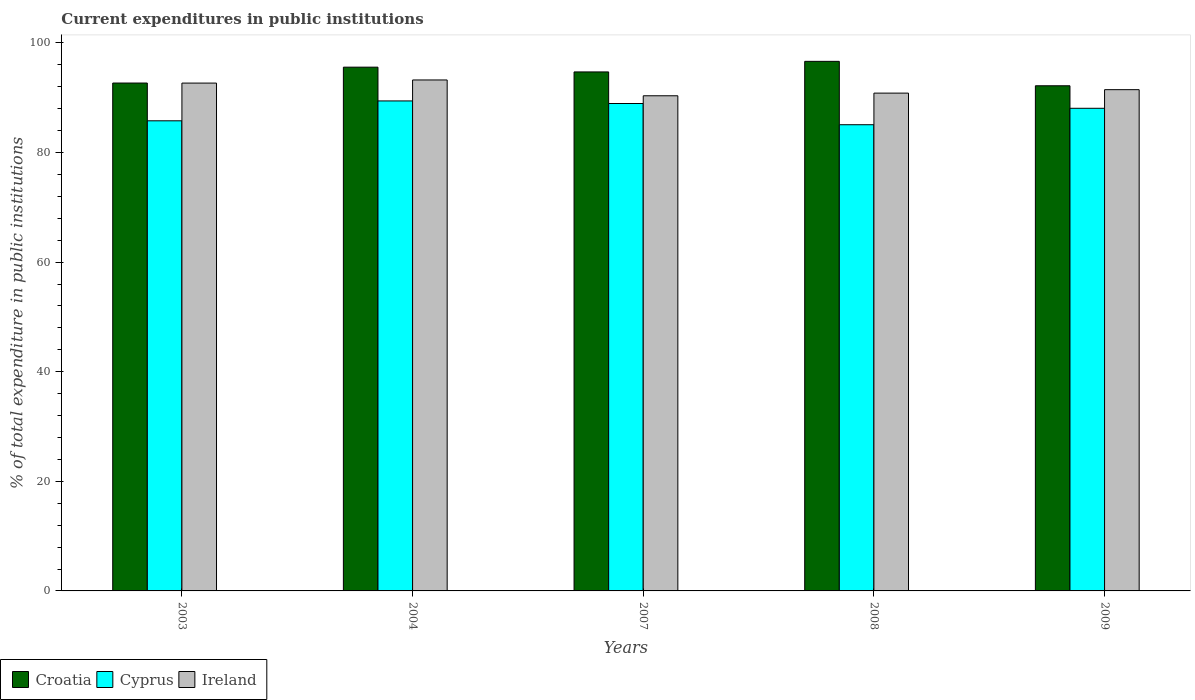How many different coloured bars are there?
Make the answer very short. 3. Are the number of bars per tick equal to the number of legend labels?
Keep it short and to the point. Yes. How many bars are there on the 3rd tick from the left?
Provide a succinct answer. 3. How many bars are there on the 1st tick from the right?
Give a very brief answer. 3. What is the current expenditures in public institutions in Croatia in 2009?
Give a very brief answer. 92.18. Across all years, what is the maximum current expenditures in public institutions in Ireland?
Keep it short and to the point. 93.24. Across all years, what is the minimum current expenditures in public institutions in Croatia?
Provide a short and direct response. 92.18. In which year was the current expenditures in public institutions in Ireland minimum?
Provide a short and direct response. 2007. What is the total current expenditures in public institutions in Ireland in the graph?
Keep it short and to the point. 458.56. What is the difference between the current expenditures in public institutions in Cyprus in 2008 and that in 2009?
Your answer should be very brief. -3. What is the difference between the current expenditures in public institutions in Cyprus in 2007 and the current expenditures in public institutions in Ireland in 2004?
Give a very brief answer. -4.3. What is the average current expenditures in public institutions in Croatia per year?
Ensure brevity in your answer.  94.35. In the year 2003, what is the difference between the current expenditures in public institutions in Cyprus and current expenditures in public institutions in Croatia?
Keep it short and to the point. -6.89. In how many years, is the current expenditures in public institutions in Ireland greater than 32 %?
Offer a terse response. 5. What is the ratio of the current expenditures in public institutions in Ireland in 2003 to that in 2007?
Give a very brief answer. 1.03. Is the current expenditures in public institutions in Croatia in 2003 less than that in 2009?
Provide a succinct answer. No. What is the difference between the highest and the second highest current expenditures in public institutions in Cyprus?
Ensure brevity in your answer.  0.47. What is the difference between the highest and the lowest current expenditures in public institutions in Ireland?
Your answer should be very brief. 2.89. In how many years, is the current expenditures in public institutions in Ireland greater than the average current expenditures in public institutions in Ireland taken over all years?
Give a very brief answer. 2. Is the sum of the current expenditures in public institutions in Ireland in 2004 and 2007 greater than the maximum current expenditures in public institutions in Cyprus across all years?
Provide a short and direct response. Yes. What does the 3rd bar from the left in 2008 represents?
Make the answer very short. Ireland. What does the 3rd bar from the right in 2007 represents?
Your answer should be compact. Croatia. How many bars are there?
Offer a very short reply. 15. What is the difference between two consecutive major ticks on the Y-axis?
Keep it short and to the point. 20. Are the values on the major ticks of Y-axis written in scientific E-notation?
Ensure brevity in your answer.  No. Where does the legend appear in the graph?
Provide a succinct answer. Bottom left. What is the title of the graph?
Make the answer very short. Current expenditures in public institutions. Does "Cyprus" appear as one of the legend labels in the graph?
Provide a short and direct response. Yes. What is the label or title of the Y-axis?
Offer a very short reply. % of total expenditure in public institutions. What is the % of total expenditure in public institutions of Croatia in 2003?
Offer a terse response. 92.68. What is the % of total expenditure in public institutions of Cyprus in 2003?
Offer a very short reply. 85.78. What is the % of total expenditure in public institutions of Ireland in 2003?
Make the answer very short. 92.67. What is the % of total expenditure in public institutions of Croatia in 2004?
Your answer should be compact. 95.57. What is the % of total expenditure in public institutions in Cyprus in 2004?
Your response must be concise. 89.41. What is the % of total expenditure in public institutions of Ireland in 2004?
Provide a short and direct response. 93.24. What is the % of total expenditure in public institutions of Croatia in 2007?
Offer a very short reply. 94.7. What is the % of total expenditure in public institutions in Cyprus in 2007?
Your answer should be very brief. 88.94. What is the % of total expenditure in public institutions in Ireland in 2007?
Provide a short and direct response. 90.35. What is the % of total expenditure in public institutions of Croatia in 2008?
Provide a short and direct response. 96.63. What is the % of total expenditure in public institutions in Cyprus in 2008?
Make the answer very short. 85.07. What is the % of total expenditure in public institutions of Ireland in 2008?
Ensure brevity in your answer.  90.84. What is the % of total expenditure in public institutions of Croatia in 2009?
Your answer should be compact. 92.18. What is the % of total expenditure in public institutions of Cyprus in 2009?
Offer a very short reply. 88.07. What is the % of total expenditure in public institutions in Ireland in 2009?
Keep it short and to the point. 91.47. Across all years, what is the maximum % of total expenditure in public institutions of Croatia?
Offer a very short reply. 96.63. Across all years, what is the maximum % of total expenditure in public institutions of Cyprus?
Provide a succinct answer. 89.41. Across all years, what is the maximum % of total expenditure in public institutions in Ireland?
Keep it short and to the point. 93.24. Across all years, what is the minimum % of total expenditure in public institutions in Croatia?
Make the answer very short. 92.18. Across all years, what is the minimum % of total expenditure in public institutions in Cyprus?
Your answer should be very brief. 85.07. Across all years, what is the minimum % of total expenditure in public institutions in Ireland?
Offer a very short reply. 90.35. What is the total % of total expenditure in public institutions of Croatia in the graph?
Offer a terse response. 471.76. What is the total % of total expenditure in public institutions in Cyprus in the graph?
Keep it short and to the point. 437.27. What is the total % of total expenditure in public institutions in Ireland in the graph?
Your answer should be compact. 458.56. What is the difference between the % of total expenditure in public institutions of Croatia in 2003 and that in 2004?
Your response must be concise. -2.89. What is the difference between the % of total expenditure in public institutions of Cyprus in 2003 and that in 2004?
Make the answer very short. -3.63. What is the difference between the % of total expenditure in public institutions in Ireland in 2003 and that in 2004?
Your answer should be compact. -0.57. What is the difference between the % of total expenditure in public institutions of Croatia in 2003 and that in 2007?
Offer a very short reply. -2.03. What is the difference between the % of total expenditure in public institutions of Cyprus in 2003 and that in 2007?
Keep it short and to the point. -3.16. What is the difference between the % of total expenditure in public institutions of Ireland in 2003 and that in 2007?
Provide a succinct answer. 2.32. What is the difference between the % of total expenditure in public institutions in Croatia in 2003 and that in 2008?
Provide a short and direct response. -3.96. What is the difference between the % of total expenditure in public institutions of Cyprus in 2003 and that in 2008?
Your answer should be compact. 0.72. What is the difference between the % of total expenditure in public institutions in Ireland in 2003 and that in 2008?
Keep it short and to the point. 1.83. What is the difference between the % of total expenditure in public institutions in Croatia in 2003 and that in 2009?
Ensure brevity in your answer.  0.5. What is the difference between the % of total expenditure in public institutions of Cyprus in 2003 and that in 2009?
Your answer should be compact. -2.29. What is the difference between the % of total expenditure in public institutions of Ireland in 2003 and that in 2009?
Make the answer very short. 1.2. What is the difference between the % of total expenditure in public institutions of Croatia in 2004 and that in 2007?
Ensure brevity in your answer.  0.87. What is the difference between the % of total expenditure in public institutions in Cyprus in 2004 and that in 2007?
Offer a very short reply. 0.47. What is the difference between the % of total expenditure in public institutions of Ireland in 2004 and that in 2007?
Provide a succinct answer. 2.89. What is the difference between the % of total expenditure in public institutions of Croatia in 2004 and that in 2008?
Provide a short and direct response. -1.06. What is the difference between the % of total expenditure in public institutions in Cyprus in 2004 and that in 2008?
Provide a short and direct response. 4.34. What is the difference between the % of total expenditure in public institutions in Ireland in 2004 and that in 2008?
Your answer should be compact. 2.4. What is the difference between the % of total expenditure in public institutions of Croatia in 2004 and that in 2009?
Give a very brief answer. 3.39. What is the difference between the % of total expenditure in public institutions of Cyprus in 2004 and that in 2009?
Your answer should be very brief. 1.34. What is the difference between the % of total expenditure in public institutions in Ireland in 2004 and that in 2009?
Your answer should be compact. 1.77. What is the difference between the % of total expenditure in public institutions in Croatia in 2007 and that in 2008?
Make the answer very short. -1.93. What is the difference between the % of total expenditure in public institutions of Cyprus in 2007 and that in 2008?
Offer a very short reply. 3.87. What is the difference between the % of total expenditure in public institutions in Ireland in 2007 and that in 2008?
Offer a terse response. -0.48. What is the difference between the % of total expenditure in public institutions of Croatia in 2007 and that in 2009?
Ensure brevity in your answer.  2.53. What is the difference between the % of total expenditure in public institutions in Cyprus in 2007 and that in 2009?
Provide a short and direct response. 0.87. What is the difference between the % of total expenditure in public institutions of Ireland in 2007 and that in 2009?
Offer a terse response. -1.12. What is the difference between the % of total expenditure in public institutions of Croatia in 2008 and that in 2009?
Ensure brevity in your answer.  4.45. What is the difference between the % of total expenditure in public institutions in Cyprus in 2008 and that in 2009?
Your answer should be compact. -3. What is the difference between the % of total expenditure in public institutions of Ireland in 2008 and that in 2009?
Give a very brief answer. -0.63. What is the difference between the % of total expenditure in public institutions of Croatia in 2003 and the % of total expenditure in public institutions of Cyprus in 2004?
Offer a very short reply. 3.27. What is the difference between the % of total expenditure in public institutions of Croatia in 2003 and the % of total expenditure in public institutions of Ireland in 2004?
Ensure brevity in your answer.  -0.56. What is the difference between the % of total expenditure in public institutions of Cyprus in 2003 and the % of total expenditure in public institutions of Ireland in 2004?
Make the answer very short. -7.45. What is the difference between the % of total expenditure in public institutions of Croatia in 2003 and the % of total expenditure in public institutions of Cyprus in 2007?
Your answer should be compact. 3.74. What is the difference between the % of total expenditure in public institutions of Croatia in 2003 and the % of total expenditure in public institutions of Ireland in 2007?
Provide a succinct answer. 2.33. What is the difference between the % of total expenditure in public institutions in Cyprus in 2003 and the % of total expenditure in public institutions in Ireland in 2007?
Your answer should be very brief. -4.57. What is the difference between the % of total expenditure in public institutions of Croatia in 2003 and the % of total expenditure in public institutions of Cyprus in 2008?
Ensure brevity in your answer.  7.61. What is the difference between the % of total expenditure in public institutions of Croatia in 2003 and the % of total expenditure in public institutions of Ireland in 2008?
Your response must be concise. 1.84. What is the difference between the % of total expenditure in public institutions in Cyprus in 2003 and the % of total expenditure in public institutions in Ireland in 2008?
Your response must be concise. -5.05. What is the difference between the % of total expenditure in public institutions in Croatia in 2003 and the % of total expenditure in public institutions in Cyprus in 2009?
Offer a terse response. 4.61. What is the difference between the % of total expenditure in public institutions of Croatia in 2003 and the % of total expenditure in public institutions of Ireland in 2009?
Keep it short and to the point. 1.21. What is the difference between the % of total expenditure in public institutions of Cyprus in 2003 and the % of total expenditure in public institutions of Ireland in 2009?
Provide a short and direct response. -5.68. What is the difference between the % of total expenditure in public institutions in Croatia in 2004 and the % of total expenditure in public institutions in Cyprus in 2007?
Keep it short and to the point. 6.63. What is the difference between the % of total expenditure in public institutions of Croatia in 2004 and the % of total expenditure in public institutions of Ireland in 2007?
Make the answer very short. 5.22. What is the difference between the % of total expenditure in public institutions of Cyprus in 2004 and the % of total expenditure in public institutions of Ireland in 2007?
Your answer should be very brief. -0.94. What is the difference between the % of total expenditure in public institutions in Croatia in 2004 and the % of total expenditure in public institutions in Cyprus in 2008?
Offer a terse response. 10.5. What is the difference between the % of total expenditure in public institutions of Croatia in 2004 and the % of total expenditure in public institutions of Ireland in 2008?
Keep it short and to the point. 4.74. What is the difference between the % of total expenditure in public institutions in Cyprus in 2004 and the % of total expenditure in public institutions in Ireland in 2008?
Your response must be concise. -1.43. What is the difference between the % of total expenditure in public institutions of Croatia in 2004 and the % of total expenditure in public institutions of Cyprus in 2009?
Give a very brief answer. 7.5. What is the difference between the % of total expenditure in public institutions of Croatia in 2004 and the % of total expenditure in public institutions of Ireland in 2009?
Provide a succinct answer. 4.11. What is the difference between the % of total expenditure in public institutions of Cyprus in 2004 and the % of total expenditure in public institutions of Ireland in 2009?
Ensure brevity in your answer.  -2.06. What is the difference between the % of total expenditure in public institutions in Croatia in 2007 and the % of total expenditure in public institutions in Cyprus in 2008?
Ensure brevity in your answer.  9.63. What is the difference between the % of total expenditure in public institutions of Croatia in 2007 and the % of total expenditure in public institutions of Ireland in 2008?
Your answer should be very brief. 3.87. What is the difference between the % of total expenditure in public institutions in Cyprus in 2007 and the % of total expenditure in public institutions in Ireland in 2008?
Your answer should be very brief. -1.89. What is the difference between the % of total expenditure in public institutions of Croatia in 2007 and the % of total expenditure in public institutions of Cyprus in 2009?
Make the answer very short. 6.63. What is the difference between the % of total expenditure in public institutions of Croatia in 2007 and the % of total expenditure in public institutions of Ireland in 2009?
Your answer should be very brief. 3.24. What is the difference between the % of total expenditure in public institutions of Cyprus in 2007 and the % of total expenditure in public institutions of Ireland in 2009?
Give a very brief answer. -2.53. What is the difference between the % of total expenditure in public institutions in Croatia in 2008 and the % of total expenditure in public institutions in Cyprus in 2009?
Provide a short and direct response. 8.56. What is the difference between the % of total expenditure in public institutions in Croatia in 2008 and the % of total expenditure in public institutions in Ireland in 2009?
Make the answer very short. 5.17. What is the difference between the % of total expenditure in public institutions of Cyprus in 2008 and the % of total expenditure in public institutions of Ireland in 2009?
Provide a succinct answer. -6.4. What is the average % of total expenditure in public institutions of Croatia per year?
Your response must be concise. 94.35. What is the average % of total expenditure in public institutions in Cyprus per year?
Provide a short and direct response. 87.45. What is the average % of total expenditure in public institutions in Ireland per year?
Provide a short and direct response. 91.71. In the year 2003, what is the difference between the % of total expenditure in public institutions of Croatia and % of total expenditure in public institutions of Cyprus?
Offer a very short reply. 6.89. In the year 2003, what is the difference between the % of total expenditure in public institutions of Croatia and % of total expenditure in public institutions of Ireland?
Keep it short and to the point. 0.01. In the year 2003, what is the difference between the % of total expenditure in public institutions of Cyprus and % of total expenditure in public institutions of Ireland?
Offer a very short reply. -6.88. In the year 2004, what is the difference between the % of total expenditure in public institutions of Croatia and % of total expenditure in public institutions of Cyprus?
Keep it short and to the point. 6.16. In the year 2004, what is the difference between the % of total expenditure in public institutions of Croatia and % of total expenditure in public institutions of Ireland?
Make the answer very short. 2.34. In the year 2004, what is the difference between the % of total expenditure in public institutions of Cyprus and % of total expenditure in public institutions of Ireland?
Offer a terse response. -3.83. In the year 2007, what is the difference between the % of total expenditure in public institutions in Croatia and % of total expenditure in public institutions in Cyprus?
Your answer should be very brief. 5.76. In the year 2007, what is the difference between the % of total expenditure in public institutions of Croatia and % of total expenditure in public institutions of Ireland?
Your answer should be compact. 4.35. In the year 2007, what is the difference between the % of total expenditure in public institutions of Cyprus and % of total expenditure in public institutions of Ireland?
Keep it short and to the point. -1.41. In the year 2008, what is the difference between the % of total expenditure in public institutions of Croatia and % of total expenditure in public institutions of Cyprus?
Ensure brevity in your answer.  11.56. In the year 2008, what is the difference between the % of total expenditure in public institutions in Croatia and % of total expenditure in public institutions in Ireland?
Offer a very short reply. 5.8. In the year 2008, what is the difference between the % of total expenditure in public institutions of Cyprus and % of total expenditure in public institutions of Ireland?
Keep it short and to the point. -5.77. In the year 2009, what is the difference between the % of total expenditure in public institutions in Croatia and % of total expenditure in public institutions in Cyprus?
Your answer should be very brief. 4.11. In the year 2009, what is the difference between the % of total expenditure in public institutions in Croatia and % of total expenditure in public institutions in Ireland?
Your answer should be very brief. 0.71. In the year 2009, what is the difference between the % of total expenditure in public institutions of Cyprus and % of total expenditure in public institutions of Ireland?
Your answer should be very brief. -3.4. What is the ratio of the % of total expenditure in public institutions in Croatia in 2003 to that in 2004?
Your answer should be very brief. 0.97. What is the ratio of the % of total expenditure in public institutions in Cyprus in 2003 to that in 2004?
Keep it short and to the point. 0.96. What is the ratio of the % of total expenditure in public institutions in Ireland in 2003 to that in 2004?
Keep it short and to the point. 0.99. What is the ratio of the % of total expenditure in public institutions in Croatia in 2003 to that in 2007?
Provide a short and direct response. 0.98. What is the ratio of the % of total expenditure in public institutions in Cyprus in 2003 to that in 2007?
Give a very brief answer. 0.96. What is the ratio of the % of total expenditure in public institutions in Ireland in 2003 to that in 2007?
Make the answer very short. 1.03. What is the ratio of the % of total expenditure in public institutions of Croatia in 2003 to that in 2008?
Give a very brief answer. 0.96. What is the ratio of the % of total expenditure in public institutions in Cyprus in 2003 to that in 2008?
Offer a terse response. 1.01. What is the ratio of the % of total expenditure in public institutions of Ireland in 2003 to that in 2008?
Ensure brevity in your answer.  1.02. What is the ratio of the % of total expenditure in public institutions in Croatia in 2003 to that in 2009?
Your response must be concise. 1.01. What is the ratio of the % of total expenditure in public institutions of Cyprus in 2003 to that in 2009?
Your response must be concise. 0.97. What is the ratio of the % of total expenditure in public institutions in Ireland in 2003 to that in 2009?
Keep it short and to the point. 1.01. What is the ratio of the % of total expenditure in public institutions in Croatia in 2004 to that in 2007?
Give a very brief answer. 1.01. What is the ratio of the % of total expenditure in public institutions in Ireland in 2004 to that in 2007?
Offer a terse response. 1.03. What is the ratio of the % of total expenditure in public institutions in Cyprus in 2004 to that in 2008?
Provide a short and direct response. 1.05. What is the ratio of the % of total expenditure in public institutions in Ireland in 2004 to that in 2008?
Offer a terse response. 1.03. What is the ratio of the % of total expenditure in public institutions in Croatia in 2004 to that in 2009?
Provide a short and direct response. 1.04. What is the ratio of the % of total expenditure in public institutions of Cyprus in 2004 to that in 2009?
Offer a terse response. 1.02. What is the ratio of the % of total expenditure in public institutions in Ireland in 2004 to that in 2009?
Keep it short and to the point. 1.02. What is the ratio of the % of total expenditure in public institutions of Croatia in 2007 to that in 2008?
Give a very brief answer. 0.98. What is the ratio of the % of total expenditure in public institutions in Cyprus in 2007 to that in 2008?
Provide a short and direct response. 1.05. What is the ratio of the % of total expenditure in public institutions of Ireland in 2007 to that in 2008?
Offer a very short reply. 0.99. What is the ratio of the % of total expenditure in public institutions of Croatia in 2007 to that in 2009?
Your answer should be compact. 1.03. What is the ratio of the % of total expenditure in public institutions in Cyprus in 2007 to that in 2009?
Make the answer very short. 1.01. What is the ratio of the % of total expenditure in public institutions of Ireland in 2007 to that in 2009?
Provide a succinct answer. 0.99. What is the ratio of the % of total expenditure in public institutions in Croatia in 2008 to that in 2009?
Give a very brief answer. 1.05. What is the ratio of the % of total expenditure in public institutions of Cyprus in 2008 to that in 2009?
Your answer should be compact. 0.97. What is the difference between the highest and the second highest % of total expenditure in public institutions in Croatia?
Provide a succinct answer. 1.06. What is the difference between the highest and the second highest % of total expenditure in public institutions of Cyprus?
Provide a short and direct response. 0.47. What is the difference between the highest and the second highest % of total expenditure in public institutions in Ireland?
Give a very brief answer. 0.57. What is the difference between the highest and the lowest % of total expenditure in public institutions of Croatia?
Provide a short and direct response. 4.45. What is the difference between the highest and the lowest % of total expenditure in public institutions of Cyprus?
Your answer should be compact. 4.34. What is the difference between the highest and the lowest % of total expenditure in public institutions of Ireland?
Offer a very short reply. 2.89. 